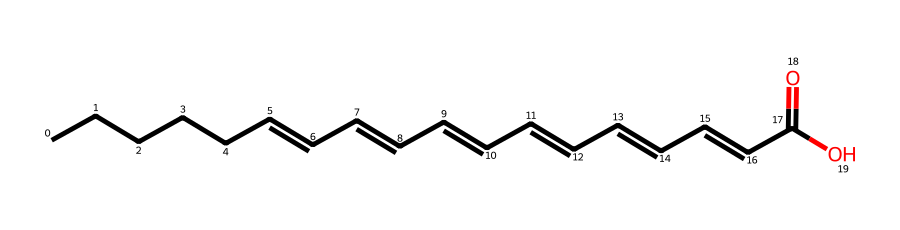What type of fatty acid is represented by this structure? The structure contains multiple double bonds, characteristic of polyunsaturated fatty acids, indicating it is an omega-3 fatty acid.
Answer: omega-3 fatty acid How many double bonds are present in this chemical? Upon examining the structure, there are three double bonds between the carbon atoms. This is identified by the '=' signs in the chain.
Answer: three What is the length of the carbon chain in this fatty acid? The chain consists of 18 carbon atoms as counted from the beginning to the end of the structure, including the carboxylic acid group.
Answer: 18 What is the functional group present in this molecule? The ending portion of the structure includes a carboxylic acid (-COOH) group, indicated by the carbonyl and hydroxyl groups.
Answer: carboxylic acid Is this fatty acid saturated or unsaturated? Given the presence of multiple double bonds, this fatty acid does not have all single bonds and is thus classified as unsaturated.
Answer: unsaturated What is the simplest form of this chemical, without the double bonds? Transforming this structure to its saturated form would involve converting all double bonds into single bonds, leading to a different representation. However, the specific name or formula was not requested here.
Answer: only saturated version 